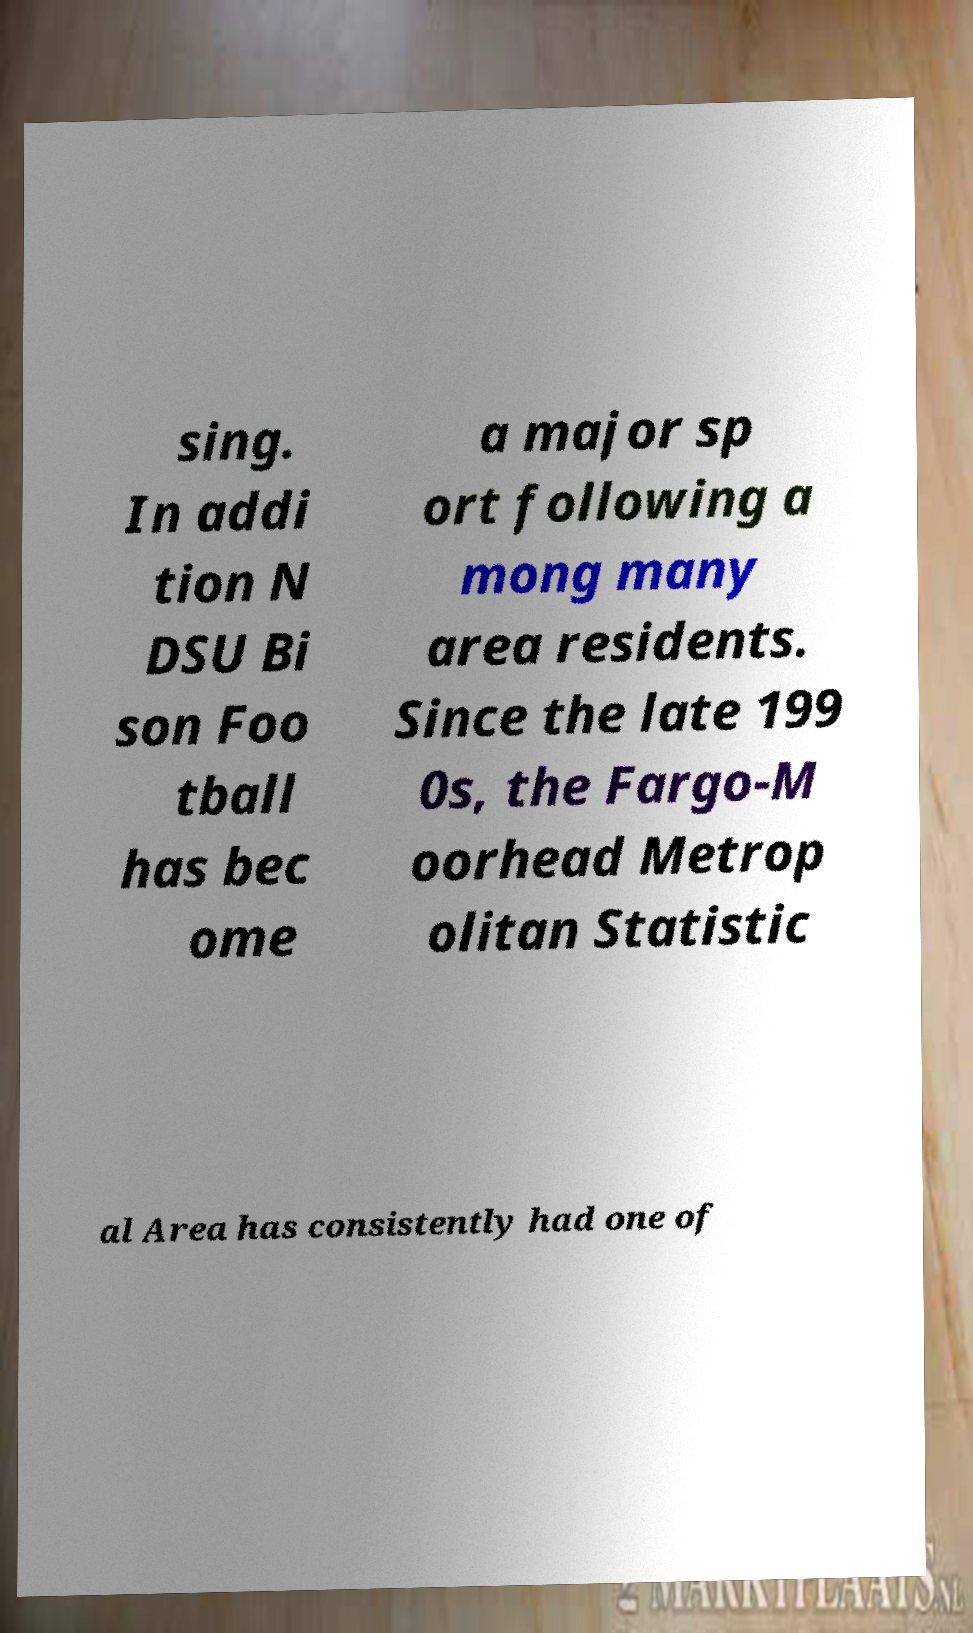Could you extract and type out the text from this image? sing. In addi tion N DSU Bi son Foo tball has bec ome a major sp ort following a mong many area residents. Since the late 199 0s, the Fargo-M oorhead Metrop olitan Statistic al Area has consistently had one of 